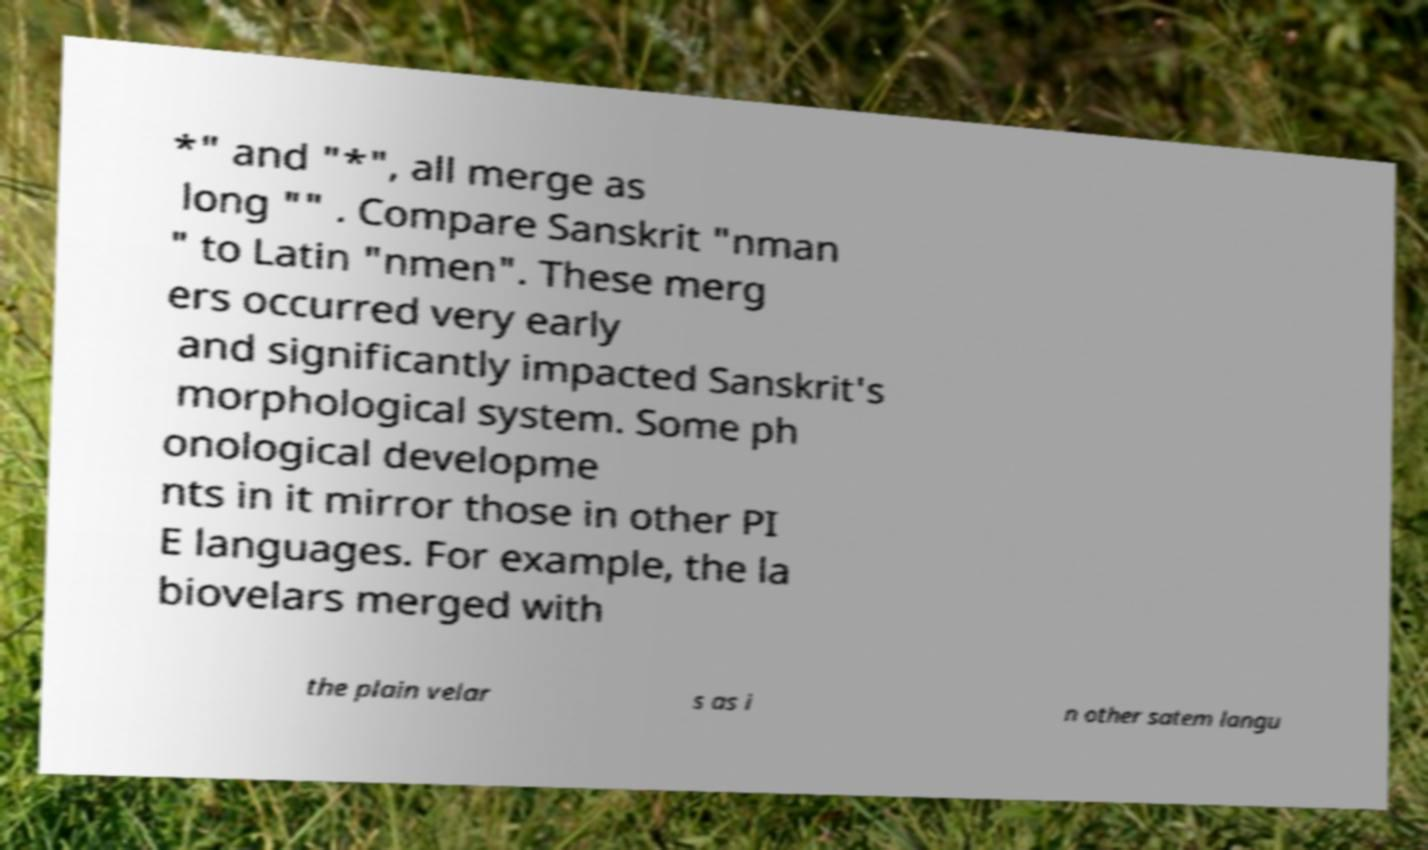Please read and relay the text visible in this image. What does it say? *" and "*", all merge as long "" . Compare Sanskrit "nman " to Latin "nmen". These merg ers occurred very early and significantly impacted Sanskrit's morphological system. Some ph onological developme nts in it mirror those in other PI E languages. For example, the la biovelars merged with the plain velar s as i n other satem langu 